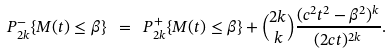<formula> <loc_0><loc_0><loc_500><loc_500>P _ { 2 k } ^ { - } \{ M ( t ) \leq \beta \} \ = \ P _ { 2 k } ^ { + } \{ M ( t ) \leq \beta \} + \binom { 2 k } { k } \frac { ( c ^ { 2 } t ^ { 2 } - \beta ^ { 2 } ) ^ { k } } { ( 2 c t ) ^ { 2 k } } .</formula> 